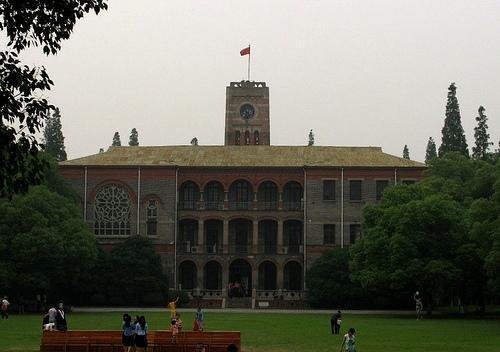How many flags are shown?
Give a very brief answer. 1. How many levels is the porch?
Give a very brief answer. 3. 